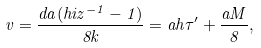Convert formula to latex. <formula><loc_0><loc_0><loc_500><loc_500>v = \frac { d a ( h i z ^ { - 1 } - 1 ) } { 8 k } = a h \tau ^ { \prime } + \frac { a M } { 8 } ,</formula> 